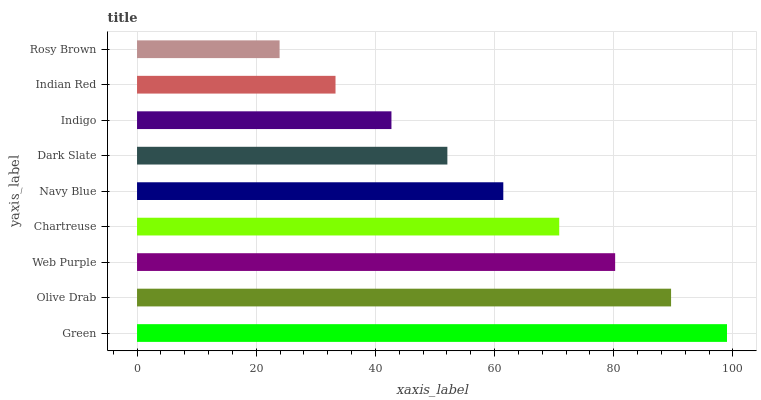Is Rosy Brown the minimum?
Answer yes or no. Yes. Is Green the maximum?
Answer yes or no. Yes. Is Olive Drab the minimum?
Answer yes or no. No. Is Olive Drab the maximum?
Answer yes or no. No. Is Green greater than Olive Drab?
Answer yes or no. Yes. Is Olive Drab less than Green?
Answer yes or no. Yes. Is Olive Drab greater than Green?
Answer yes or no. No. Is Green less than Olive Drab?
Answer yes or no. No. Is Navy Blue the high median?
Answer yes or no. Yes. Is Navy Blue the low median?
Answer yes or no. Yes. Is Rosy Brown the high median?
Answer yes or no. No. Is Dark Slate the low median?
Answer yes or no. No. 